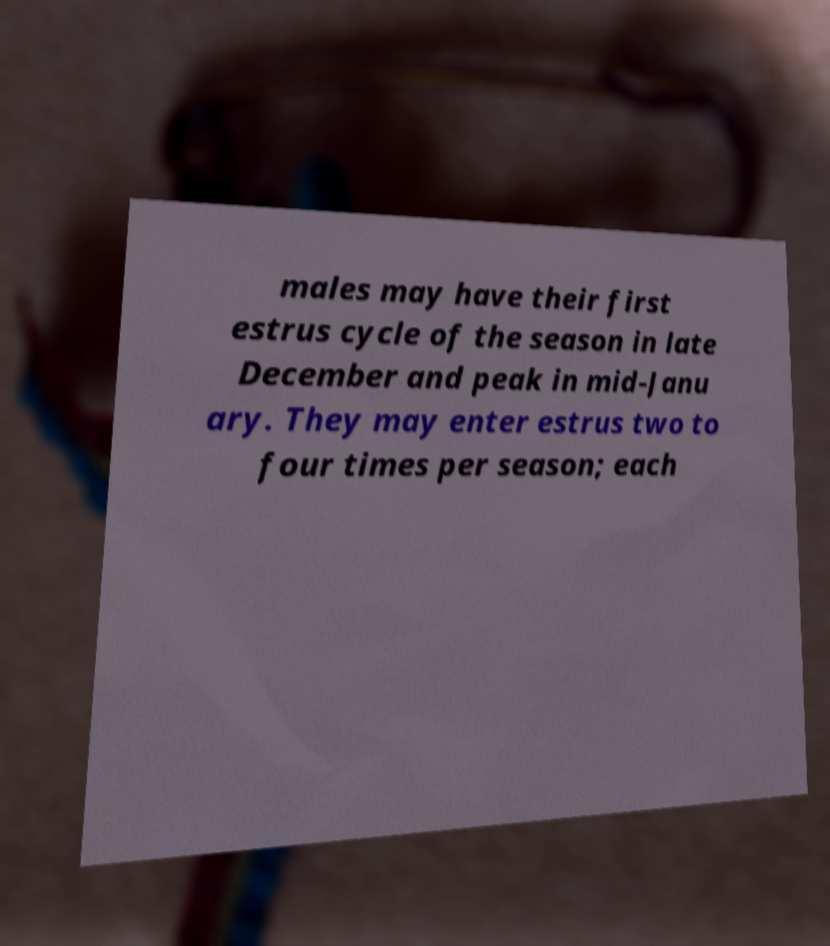What messages or text are displayed in this image? I need them in a readable, typed format. males may have their first estrus cycle of the season in late December and peak in mid-Janu ary. They may enter estrus two to four times per season; each 